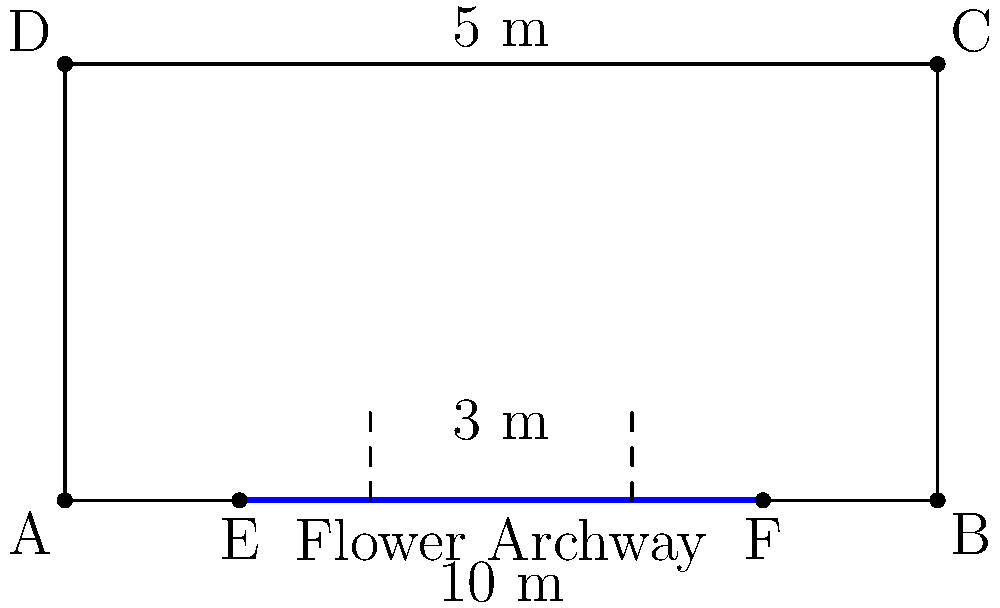A young couple wants to install a flower archway for their dream wedding ceremony. The site plan shows a rectangular area of 10 m x 5 m. The archway will span 6 m along the bottom edge of the site, centered. To ensure stability, two support columns need to be placed 3 m apart. What is the distance from the left edge of the site to the center of the left support column? Let's approach this step-by-step:

1) The site is 10 m wide and 5 m deep.

2) The archway spans 6 m and is centered on the bottom edge of the site.
   This means there is $(10 - 6) / 2 = 2$ m of space on each side of the archway.

3) The support columns need to be placed 3 m apart.
   Since the archway is 6 m wide, this leaves $(6 - 3) / 2 = 1.5$ m from each end of the archway to the nearest support column.

4) To find the distance from the left edge of the site to the center of the left support column, we add:
   - The space from the left edge to the start of the archway: 2 m
   - The distance from the start of the archway to the left support column: 1.5 m

5) Therefore, the total distance is: $2 + 1.5 = 3.5$ m

This places the left support column exactly at the position marked by the left dashed line in the diagram.
Answer: 3.5 m 